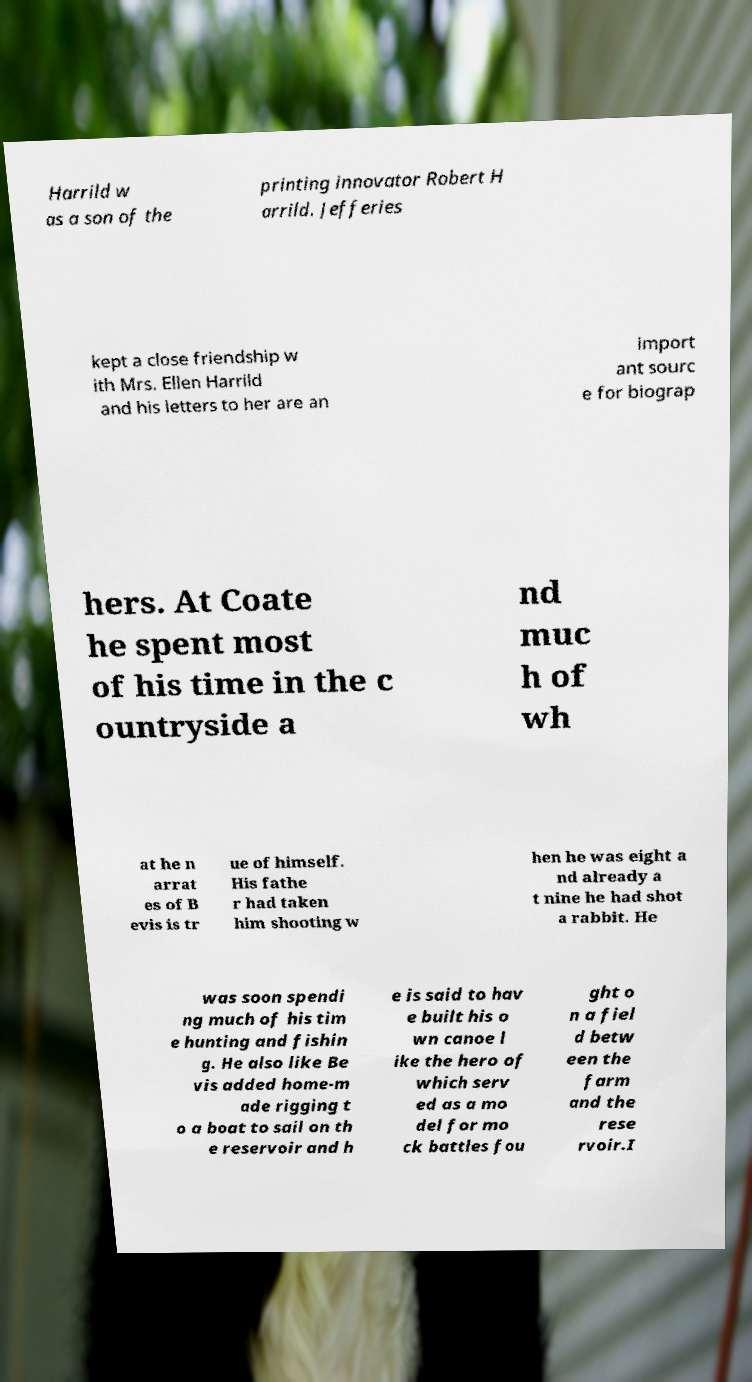Please identify and transcribe the text found in this image. Harrild w as a son of the printing innovator Robert H arrild. Jefferies kept a close friendship w ith Mrs. Ellen Harrild and his letters to her are an import ant sourc e for biograp hers. At Coate he spent most of his time in the c ountryside a nd muc h of wh at he n arrat es of B evis is tr ue of himself. His fathe r had taken him shooting w hen he was eight a nd already a t nine he had shot a rabbit. He was soon spendi ng much of his tim e hunting and fishin g. He also like Be vis added home-m ade rigging t o a boat to sail on th e reservoir and h e is said to hav e built his o wn canoe l ike the hero of which serv ed as a mo del for mo ck battles fou ght o n a fiel d betw een the farm and the rese rvoir.I 